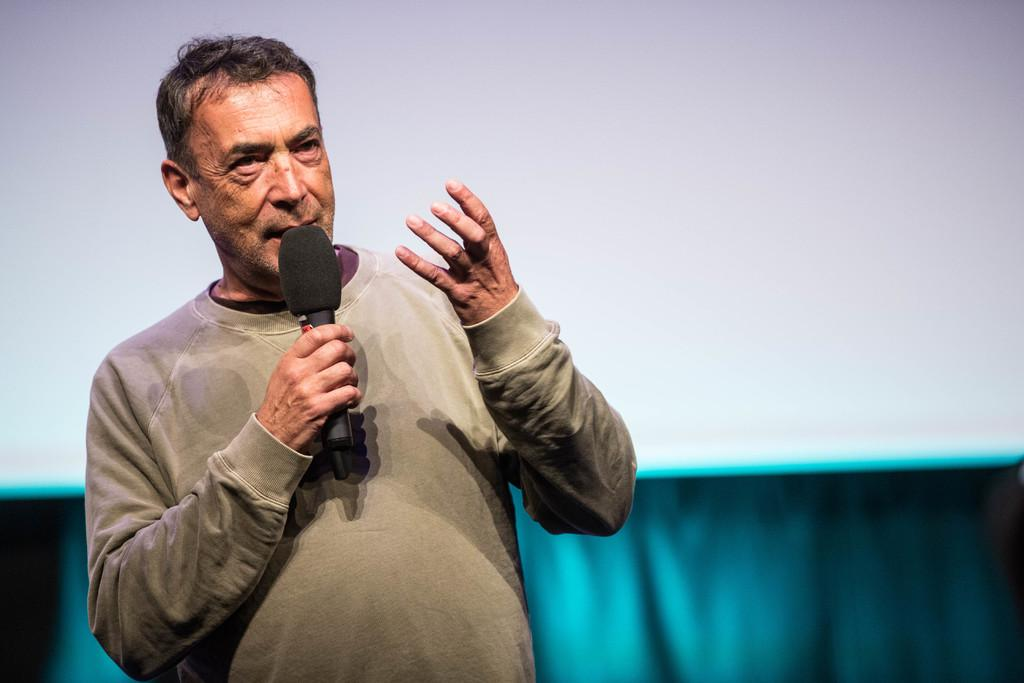What is the main subject of the image? There is a person in the image. What is the person wearing? The person is wearing a t-shirt. What is the person doing in the image? The person is standing and holding a microphone. Can you describe the background of the image? The background of the image is white and blue colored. How many family members are visible in the image? There is no family present in the image, only a single person holding a microphone. Are there any slaves depicted in the image? There is no mention or depiction of slavery in the image; it features a person holding a microphone against a white and blue background. 